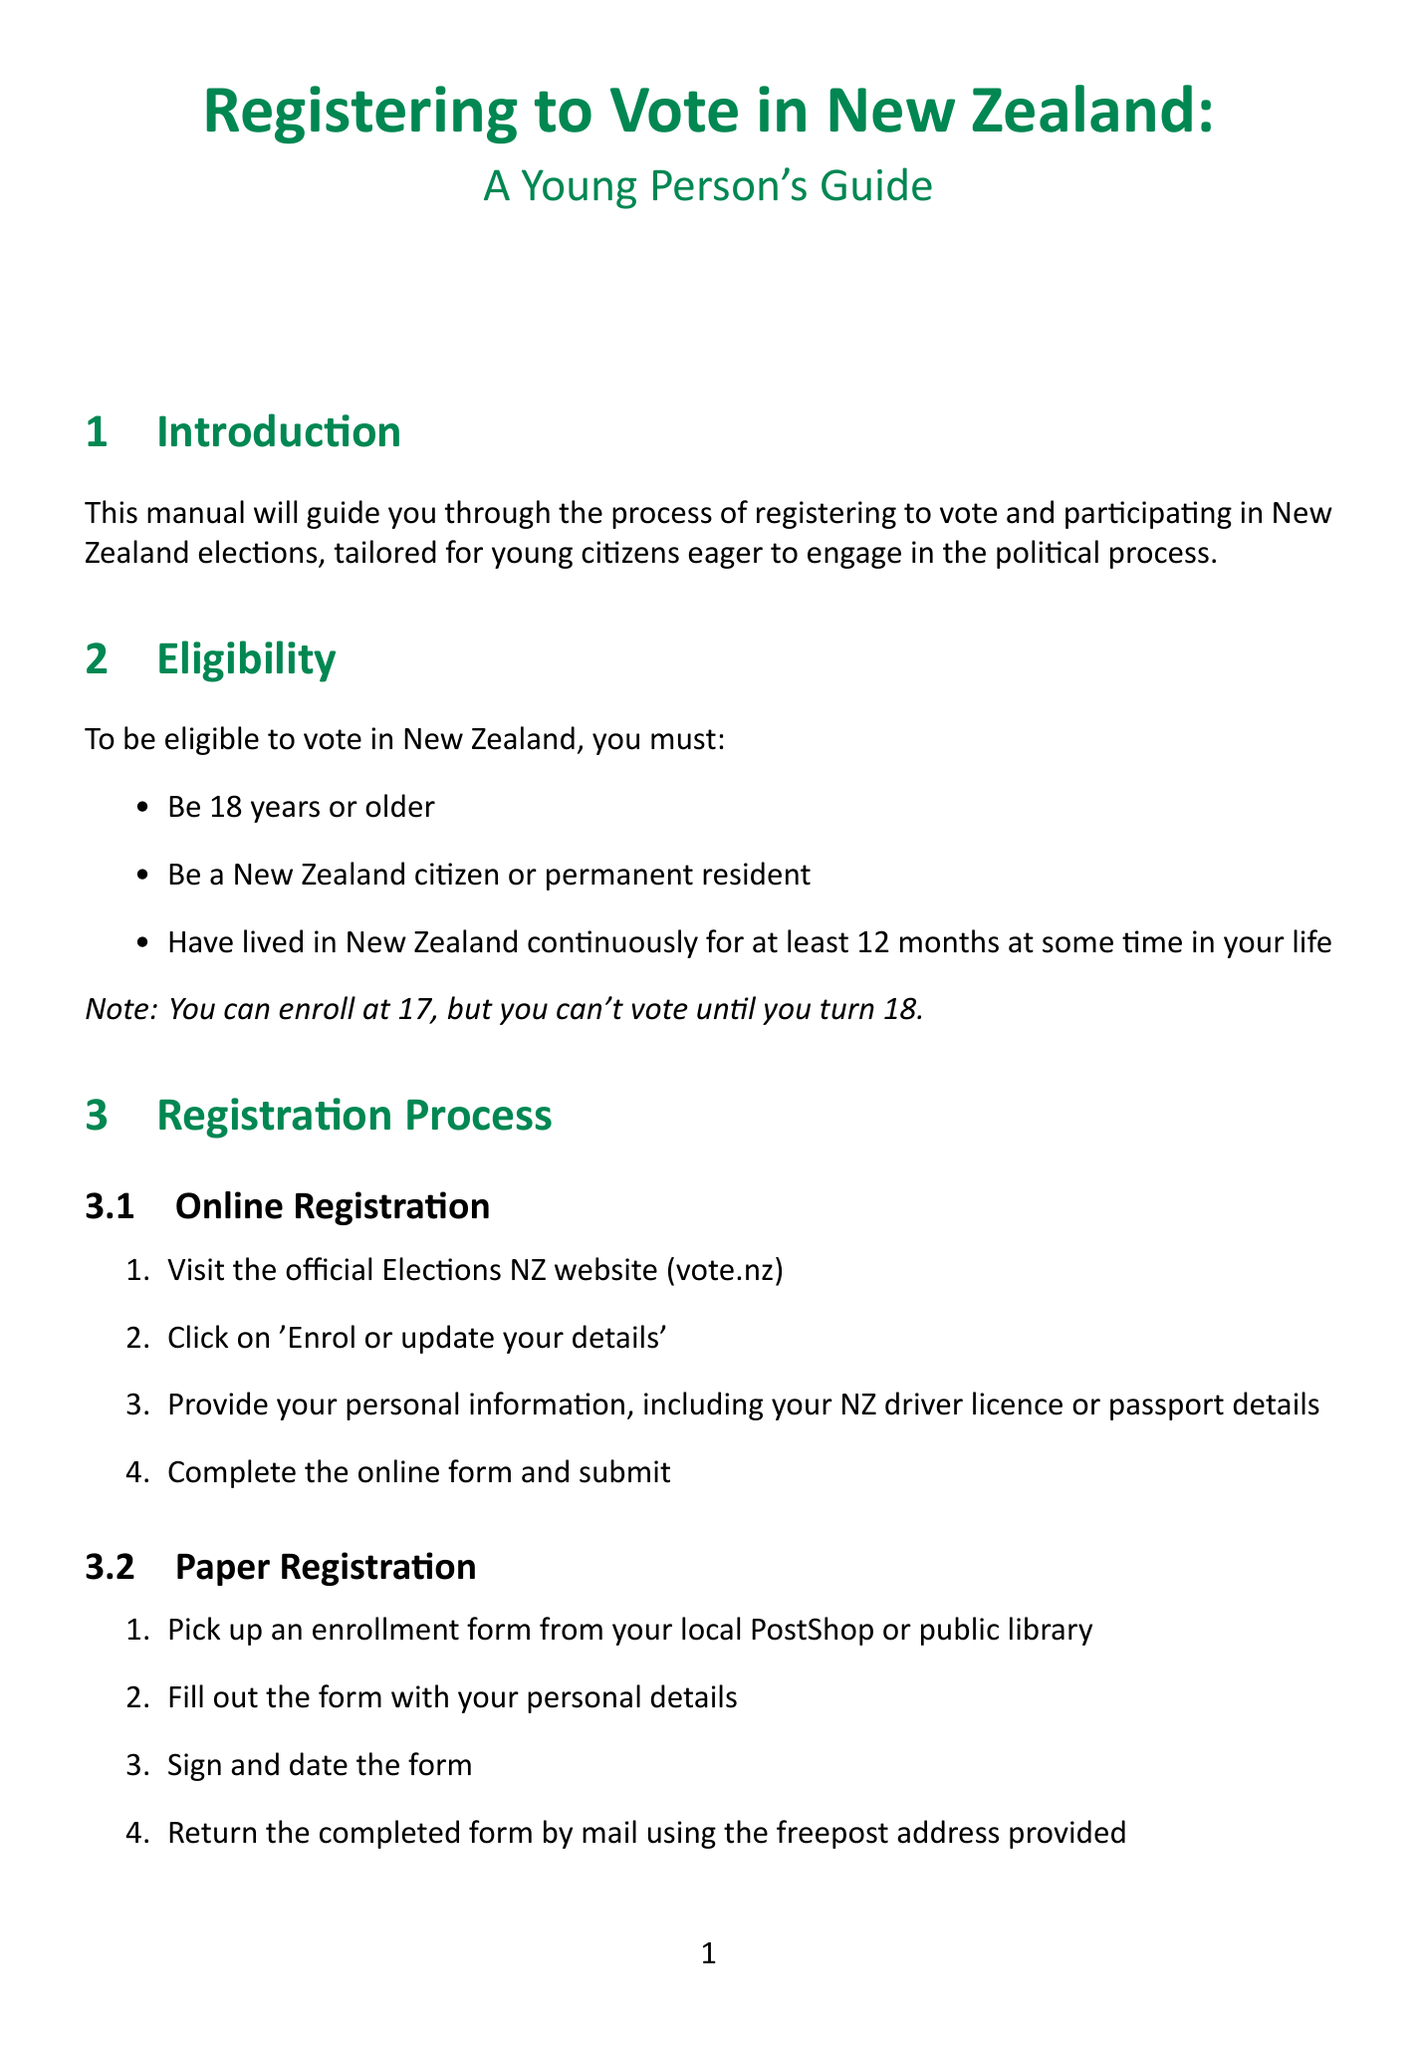What is the minimum age to register? The minimum age to register to vote is 17, but voting can only take place once you are 18.
Answer: 17 What are the major political parties listed? The document lists several major political parties including those such as Labour Party, National Party, and Green Party.
Answer: Labour Party, National Party, Green Party, ACT New Zealand, New Zealand First, Māori Party What is the helpline number for the Electoral Commission? The document provides a helpline number for those needing assistance with voter registration or information.
Answer: 0800 36 76 56 How many weeks before election day is advance voting available? The document states that advance voting is usually available some time prior to election day.
Answer: 2 weeks What should you bring to standard voting? The document specifies what items to bring when voting at a polling place on election day.
Answer: EasyVote card, form of identification What is one way to update your enrollment details? The document outlines methods for updating personal information and enrollment details.
Answer: Update online through vote.nz What does the Youth Engagement section highlight? This section lists initiatives aimed at engaging young citizens in the political process.
Answer: Youth Parliament, school-based programs What is a requirement for voter eligibility regarding residency? The eligibility requirements specify how long a person must have lived in New Zealand to be eligible to vote.
Answer: 12 months continuous residency 